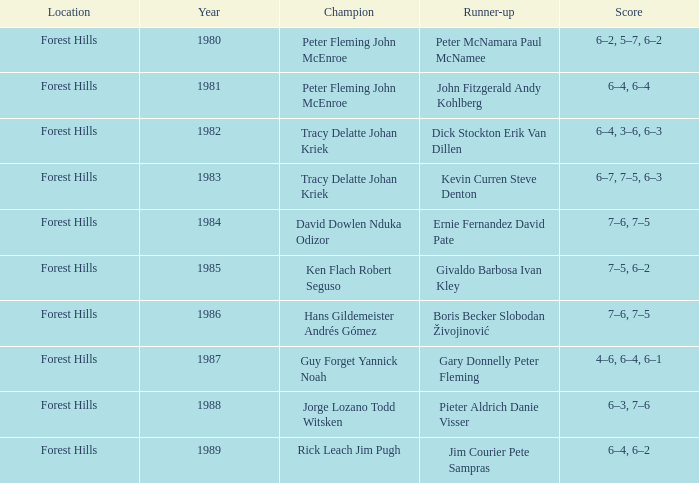Who were the champions in 1988? Jorge Lozano Todd Witsken. 